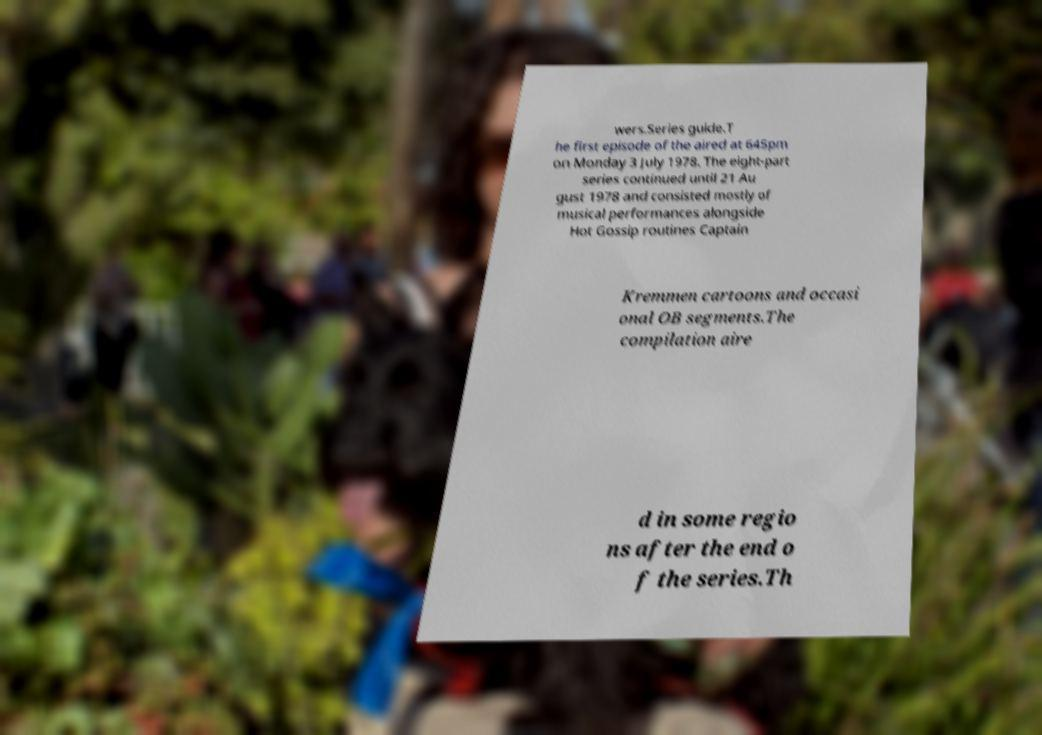I need the written content from this picture converted into text. Can you do that? wers.Series guide.T he first episode of the aired at 645pm on Monday 3 July 1978. The eight-part series continued until 21 Au gust 1978 and consisted mostly of musical performances alongside Hot Gossip routines Captain Kremmen cartoons and occasi onal OB segments.The compilation aire d in some regio ns after the end o f the series.Th 